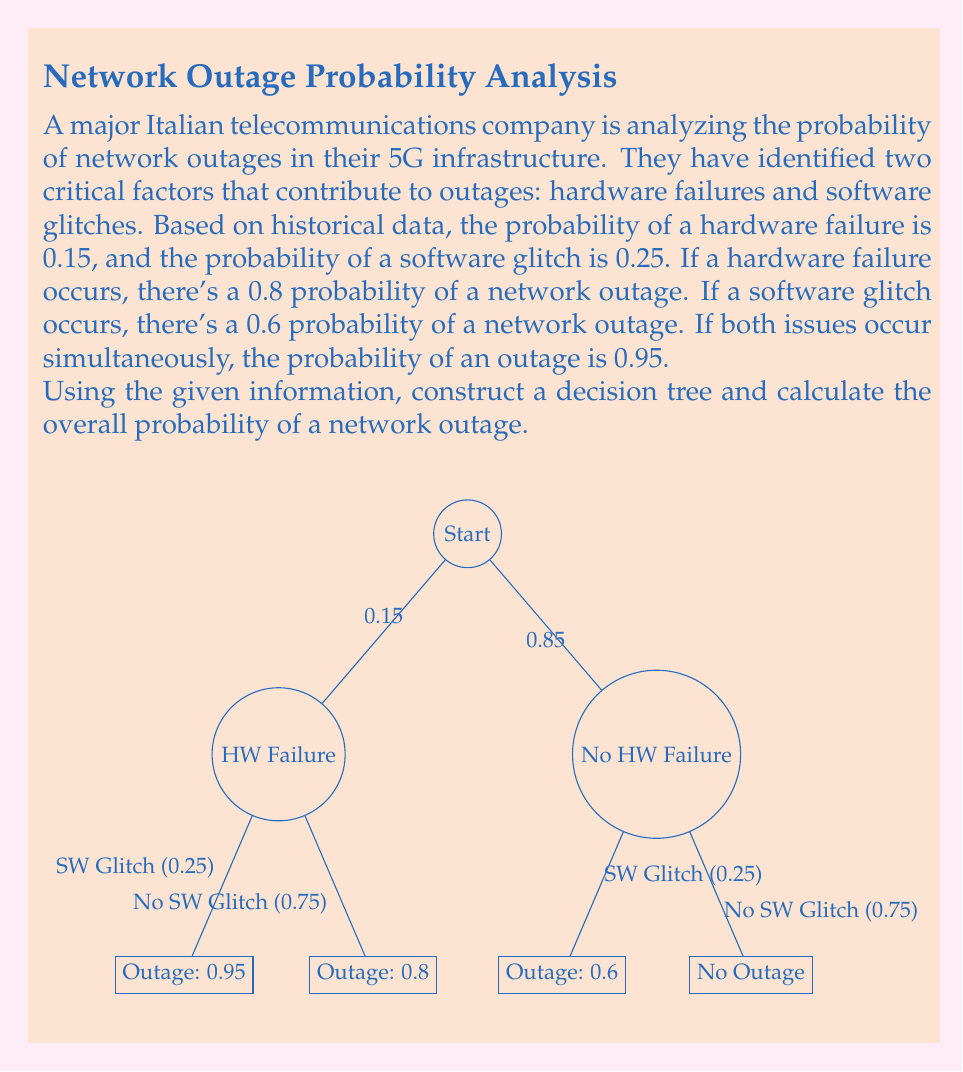Teach me how to tackle this problem. Let's approach this step-by-step using the decision tree method:

1) First, we need to identify all possible scenarios:
   a) Hardware failure and software glitch
   b) Hardware failure, no software glitch
   c) No hardware failure, software glitch
   d) No hardware failure, no software glitch

2) Now, let's calculate the probability of each scenario:
   a) P(HW & SW) = 0.15 * 0.25 = 0.0375
   b) P(HW & no SW) = 0.15 * 0.75 = 0.1125
   c) P(no HW & SW) = 0.85 * 0.25 = 0.2125
   d) P(no HW & no SW) = 0.85 * 0.75 = 0.6375

3) Next, we calculate the probability of an outage for each scenario:
   a) P(Outage | HW & SW) = 0.95
   b) P(Outage | HW & no SW) = 0.8
   c) P(Outage | no HW & SW) = 0.6
   d) P(Outage | no HW & no SW) = 0

4) Now, we can calculate the probability of an outage for each scenario:
   a) P(Outage & HW & SW) = 0.0375 * 0.95 = 0.035625
   b) P(Outage & HW & no SW) = 0.1125 * 0.8 = 0.09
   c) P(Outage & no HW & SW) = 0.2125 * 0.6 = 0.1275
   d) P(Outage & no HW & no SW) = 0.6375 * 0 = 0

5) The total probability of an outage is the sum of these probabilities:

   $$P(\text{Outage}) = 0.035625 + 0.09 + 0.1275 + 0 = 0.253125$$

Therefore, the overall probability of a network outage is 0.253125 or 25.3125%.
Answer: 0.253125 (or 25.3125%) 